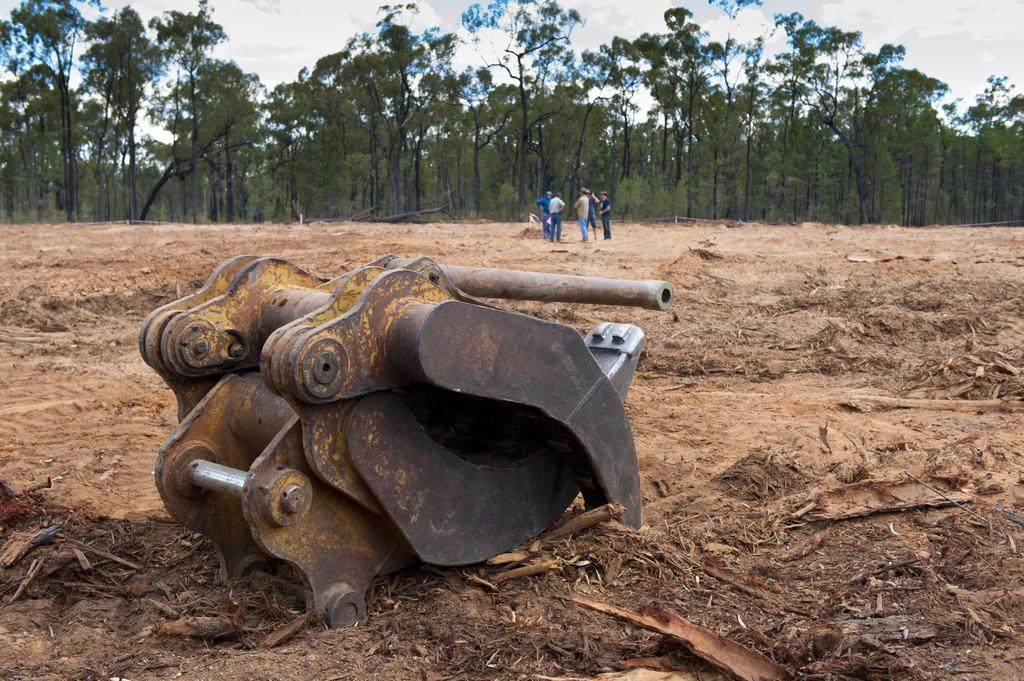What type of object is on the ground in the image? There is a metal object on the ground in the image. Who or what is present in the image besides the metal object? There are people standing in the image. What type of natural environment can be seen in the image? There are trees visible in the image. What is visible at the top of the image? The sky is visible at the top of the image. Are there any snakes visible in the image? There are no snakes present in the image. Is there a cave in the image? There is no cave visible in the image. 